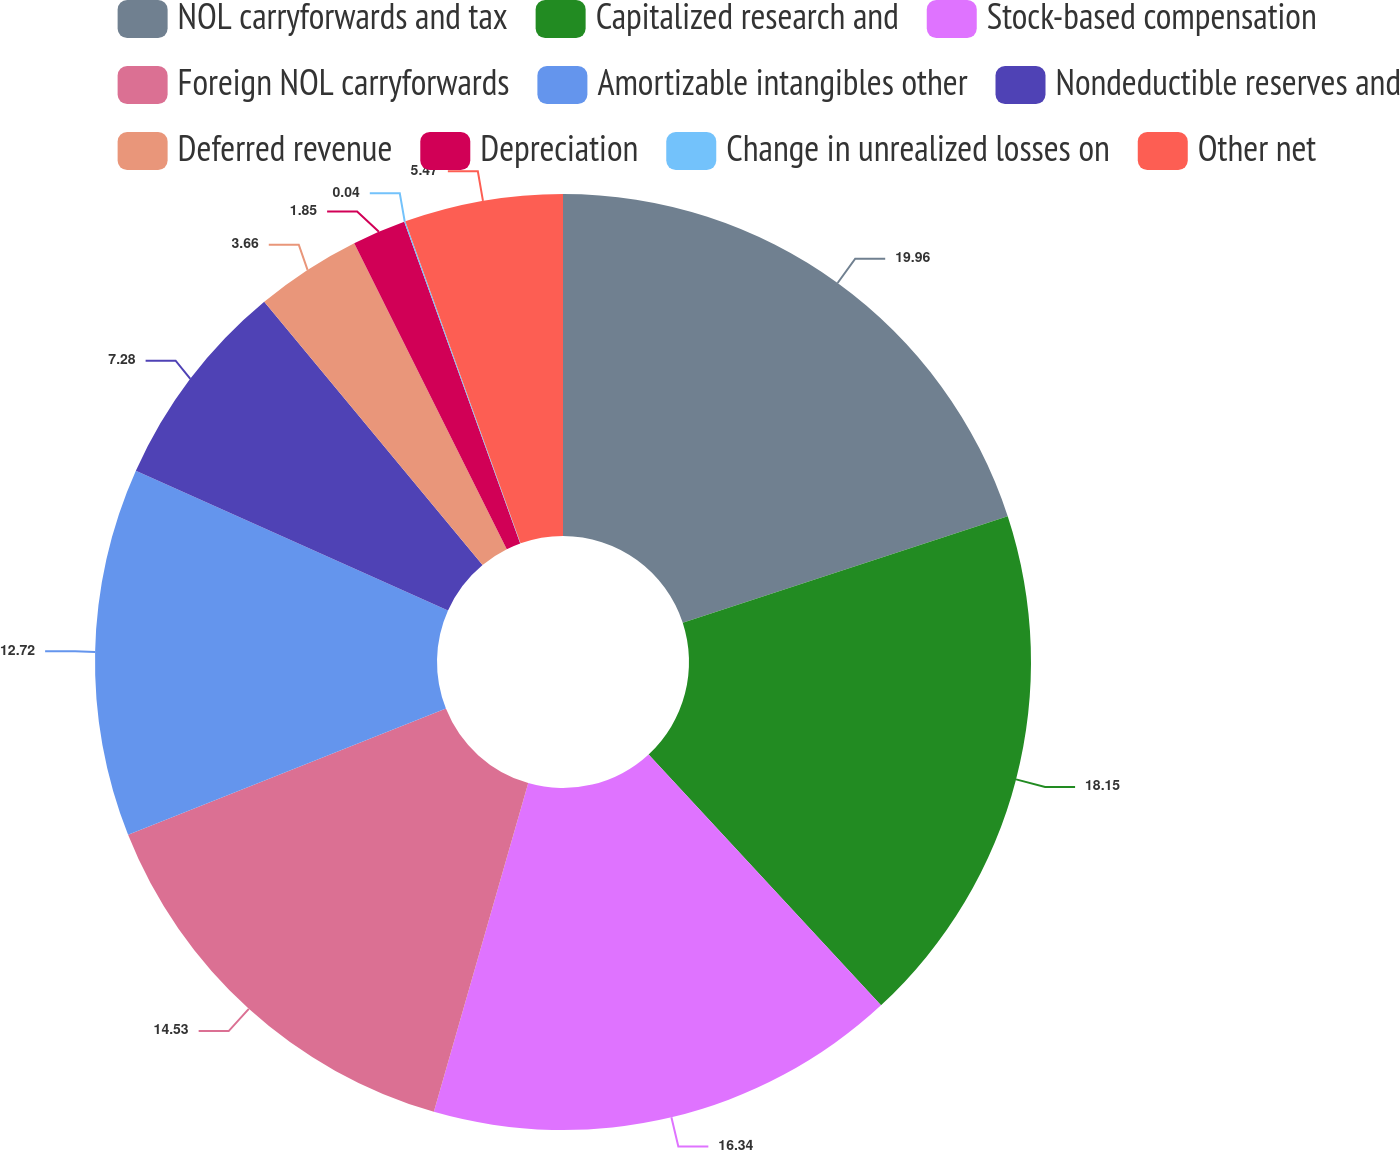Convert chart to OTSL. <chart><loc_0><loc_0><loc_500><loc_500><pie_chart><fcel>NOL carryforwards and tax<fcel>Capitalized research and<fcel>Stock-based compensation<fcel>Foreign NOL carryforwards<fcel>Amortizable intangibles other<fcel>Nondeductible reserves and<fcel>Deferred revenue<fcel>Depreciation<fcel>Change in unrealized losses on<fcel>Other net<nl><fcel>19.96%<fcel>18.15%<fcel>16.34%<fcel>14.53%<fcel>12.72%<fcel>7.28%<fcel>3.66%<fcel>1.85%<fcel>0.04%<fcel>5.47%<nl></chart> 